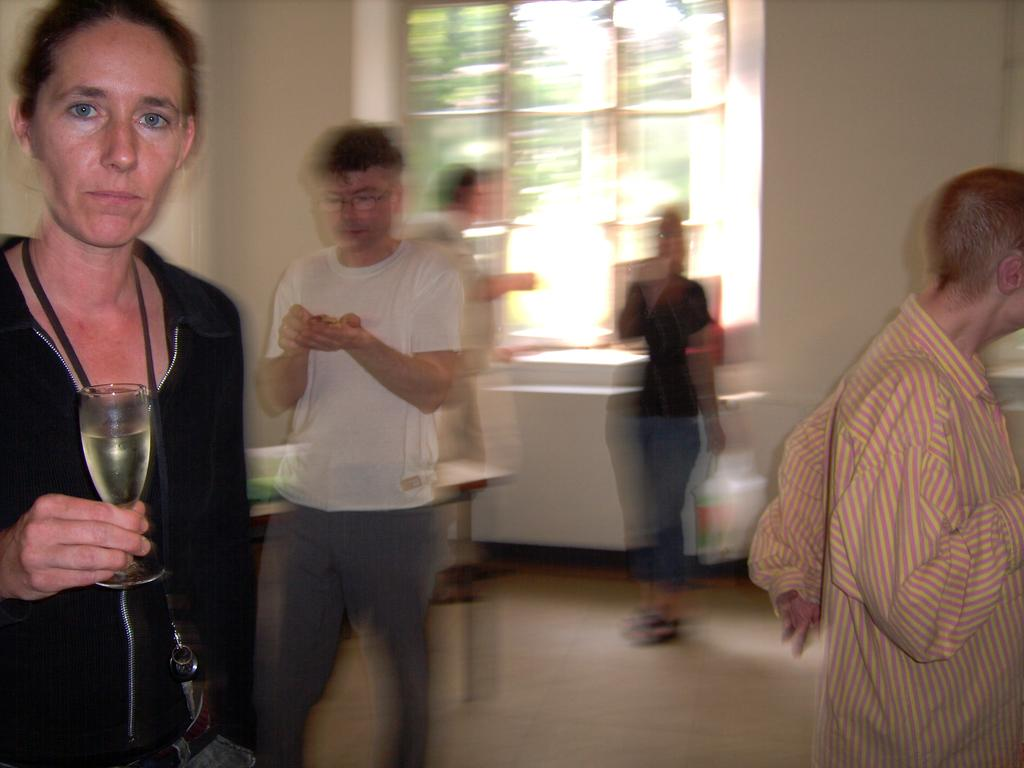What is the woman in the image holding? The woman is holding a wine glass. How many people are standing in the background of the image? There are four persons standing in the background. What can be found on the table in the image? There are objects placed on the table. Can you describe the setting of the image? The image features a woman holding a wine glass, with four people standing in the background and a table with objects. How much time does the woman spend crushing the objects on the table in the image? There is no indication in the image that the woman is crushing any objects on the table, so it is not possible to determine how much time she spends doing so. 